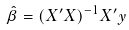<formula> <loc_0><loc_0><loc_500><loc_500>\hat { \beta } = ( X ^ { \prime } X ) ^ { - 1 } X ^ { \prime } y</formula> 